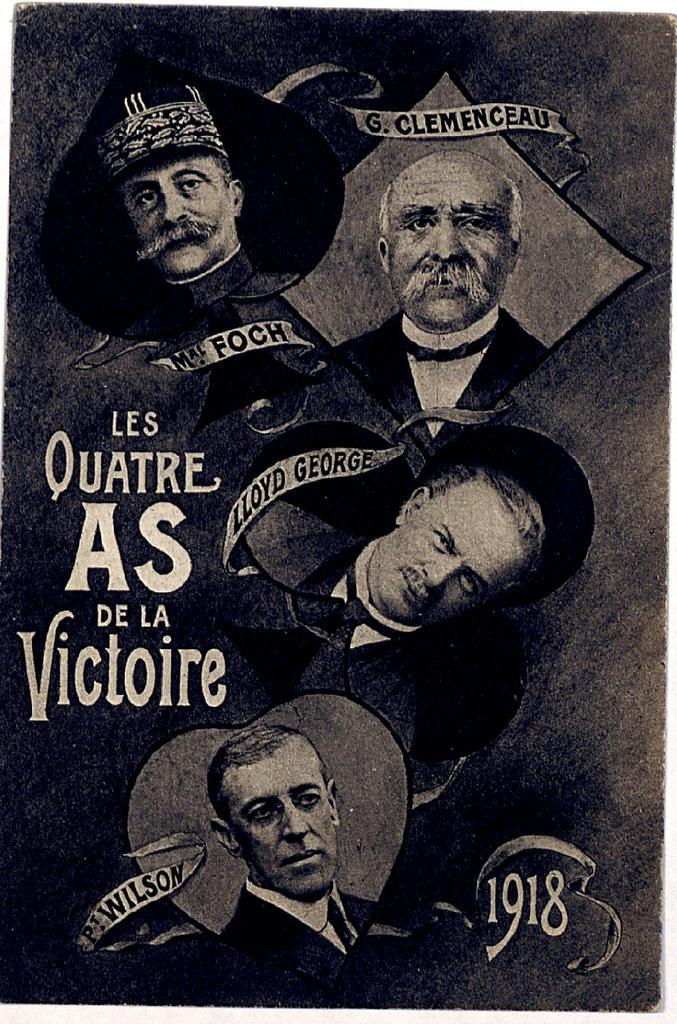What is the main subject in the image? There is a poster in the image. What type of milk is being poured into the bat's bowl in the image? There is no milk, bat, or bowl present in the image; it only features a poster. 